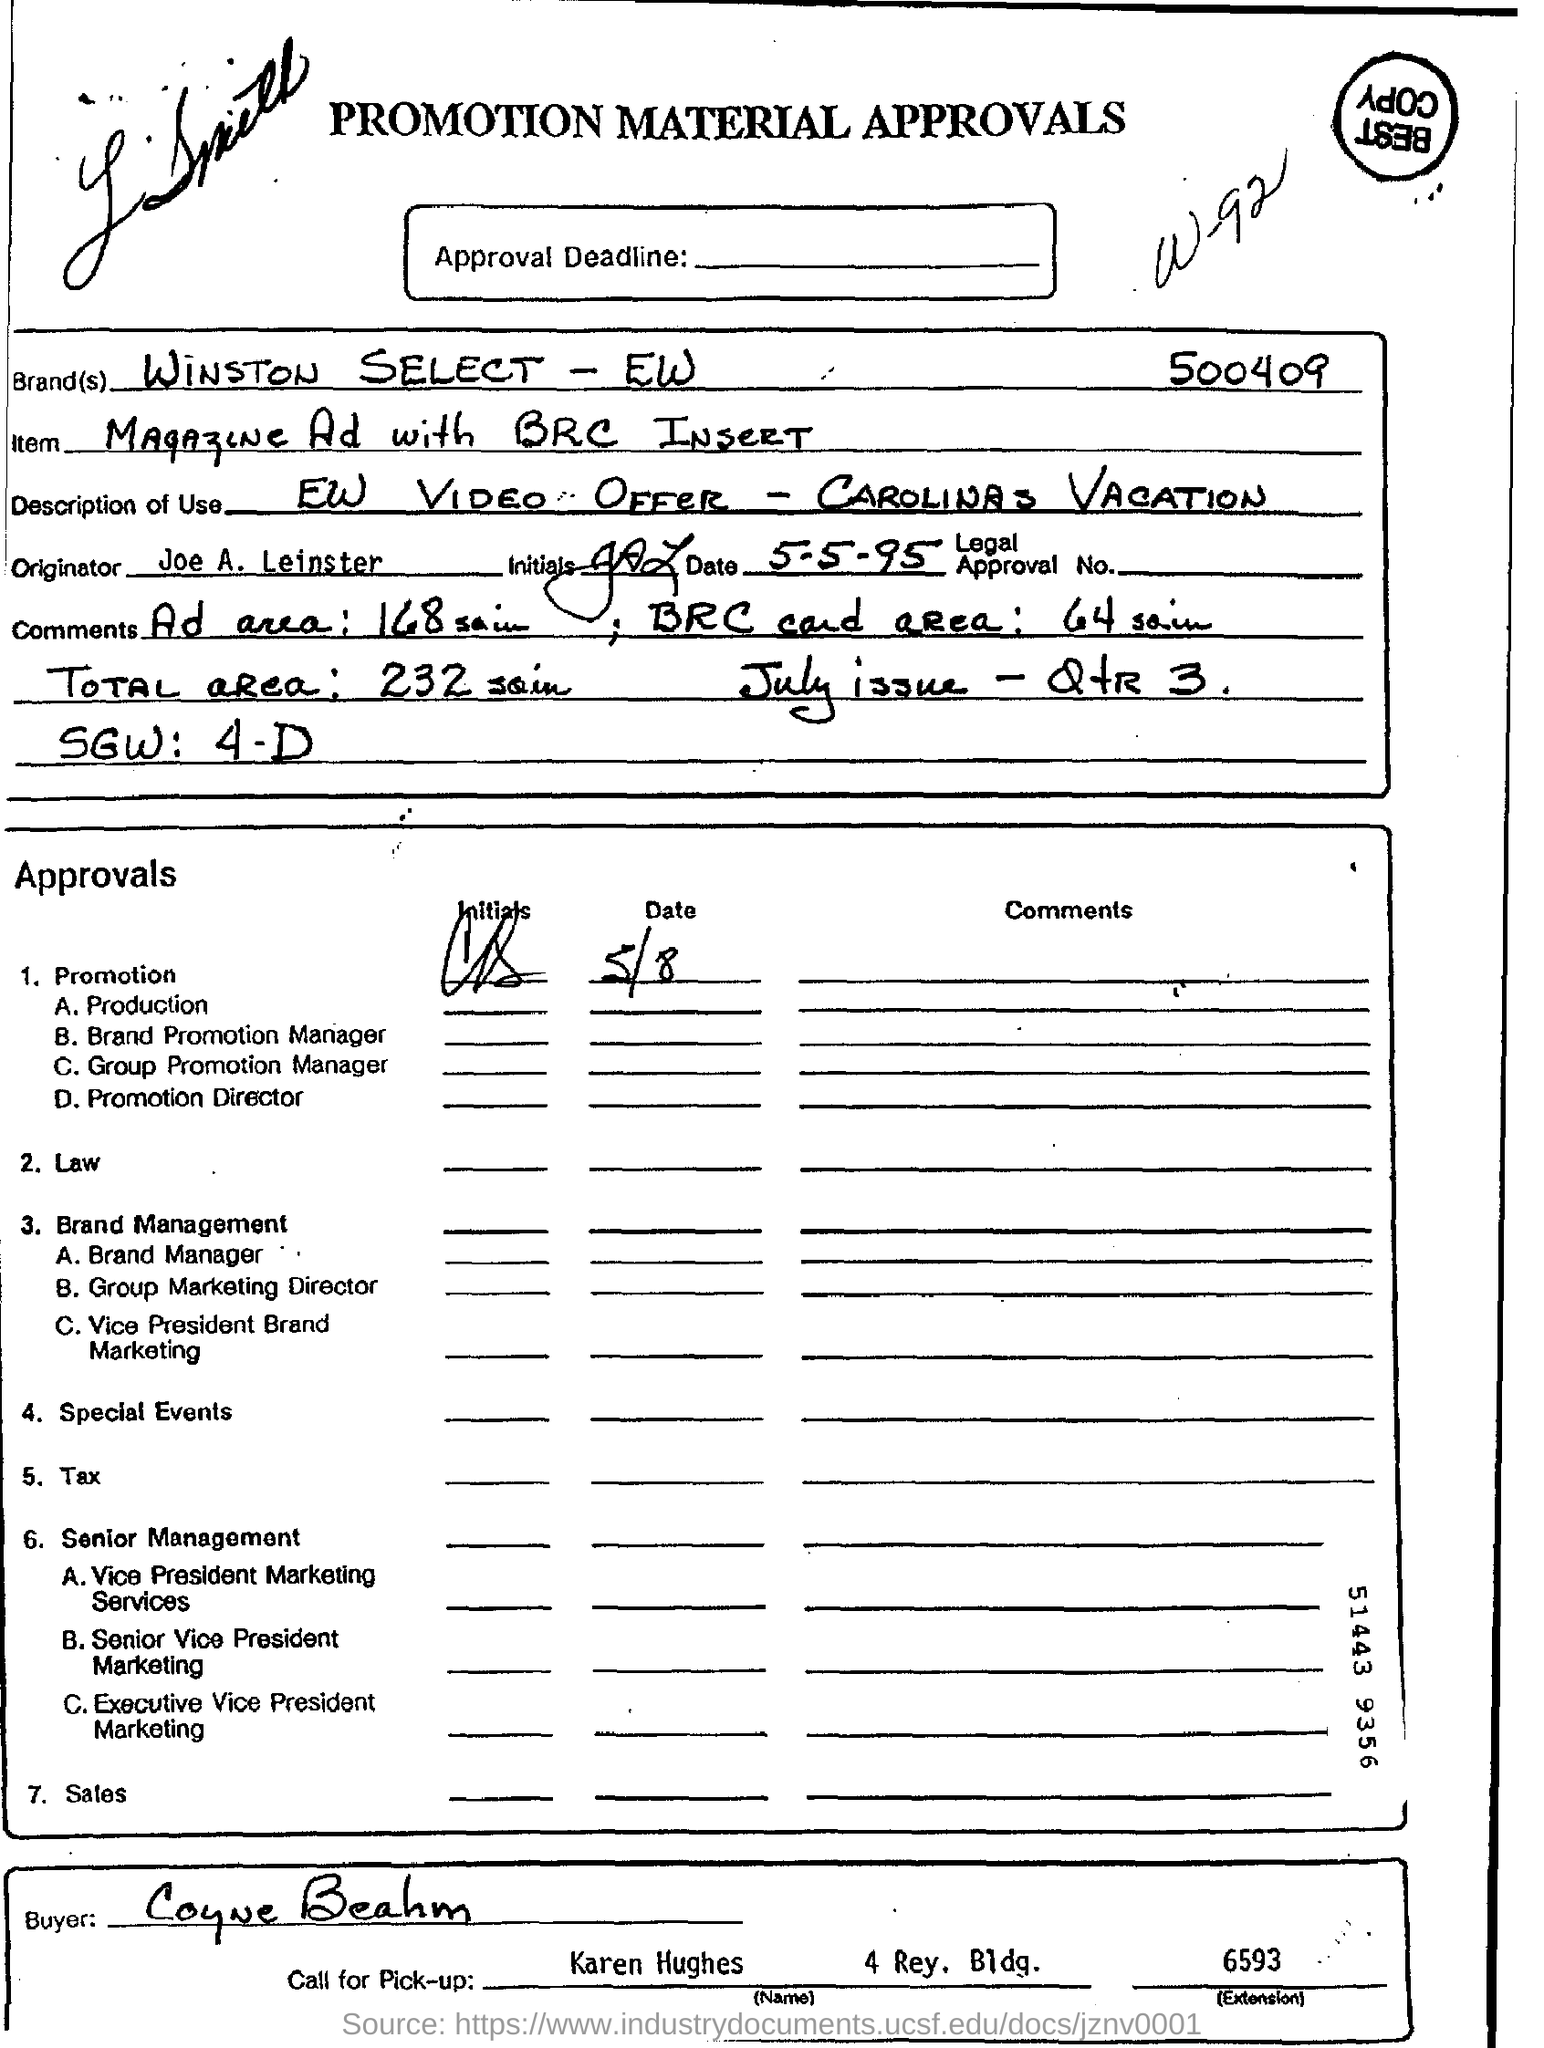Draw attention to some important aspects in this diagram. The advertisement will be included in the July issue of the magazine, as indicated by the notation 'July issue - QtR 3...'. The originator is Joe A. Leinster. The item being described is a magazine with an advertisement that includes a BRC insert. The brand "Winston Select - EW" is mentioned in the form with the serial number 500409... The total area is 232 square inches. 